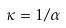Convert formula to latex. <formula><loc_0><loc_0><loc_500><loc_500>\kappa = 1 / \alpha</formula> 